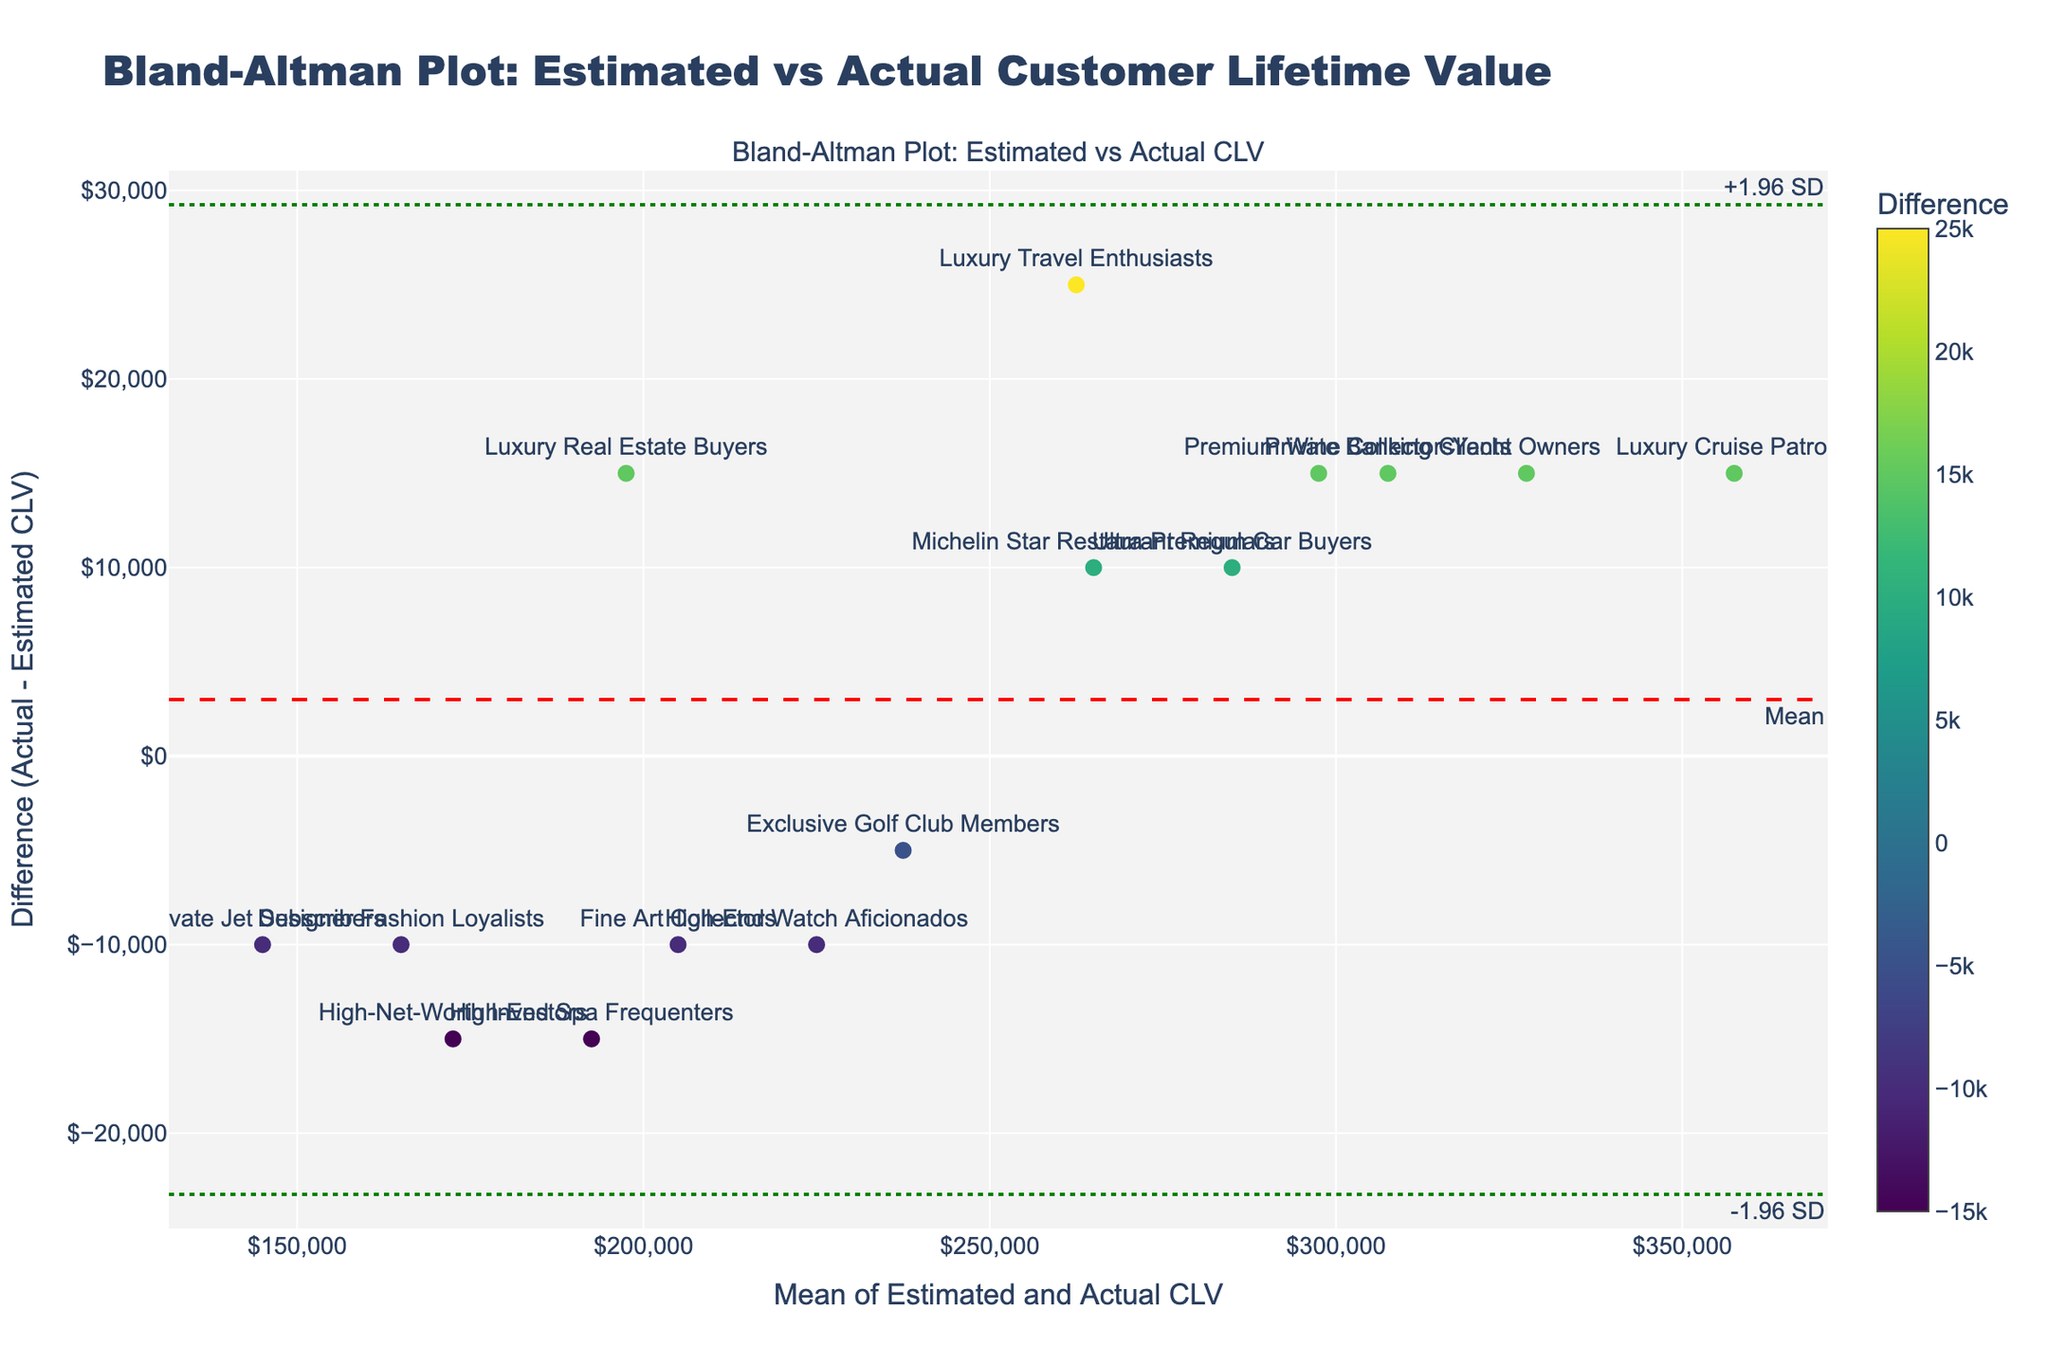what is the title of the plot? The title is located at the top of the plot.
Answer: Bland-Altman Plot: Estimated vs Actual Customer Lifetime Value How many customer segments are represented on the plot? Each marker represents a customer segment in the plot. By counting the markers, we can determine the number of customer segments.
Answer: 15 What is the segment with the largest positive difference between actual and estimated CLV? Look for the segment with the highest marker on the positive y-axis (difference).
Answer: Yacht Owners What two segments have approximately the same mean CLV but differ widely in their differences? Locate markers that are close together on the x-axis (mean CLV) but far apart on the y-axis (differences).
Answer: Private Banking Clients and Luxury Cruise Patrons What are the upper and lower limits of agreement? The upper and lower limits of agreement are indicated by dashed lines on the plot. The values are written near the lines.
Answer: +1.96 SD and -1.96 SD What does a point above the red dashed line indicate? Points above the red dashed line (mean line) have higher actual CLV than estimated CLV.
Answer: Actual CLV is higher than estimated CLV Which segment has the mean CLV closest to $250,000? Locate the marker nearest to $250,000 on the x-axis (mean CLV).
Answer: Michelin Star Restaurant Regulars Which customer segment shows the smallest difference between actual and estimated CLV? Find the marker closest to the horizontal zero line (y=0).
Answer: Exclusive Golf Club Members What is the overall trend in the differences between estimated and actual CLV across segments? Look at the scatter of the markers across the y-axis to understand the pattern.
Answer: Differences vary, but no clear trend Which segment falls outside the limits of agreement? Identify markers outside the two dashed lines marking +1.96 SD and -1.96 SD.
Answer: Luxury Real Estate Buyers 